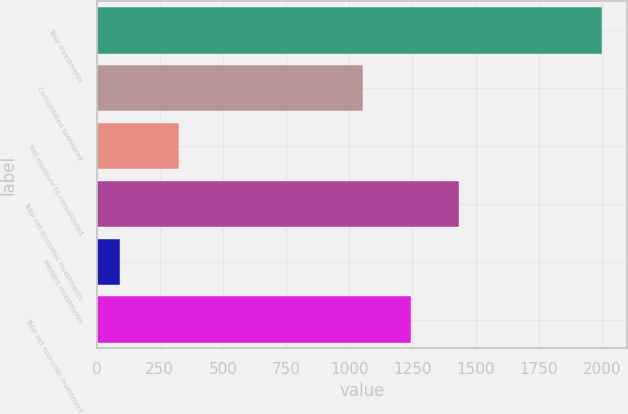Convert chart. <chart><loc_0><loc_0><loc_500><loc_500><bar_chart><fcel>Total investments<fcel>Consolidated sponsored<fcel>Net exposure to consolidated<fcel>Total net economic investments<fcel>Hedged investments<fcel>Total net economic investment<nl><fcel>2000<fcel>1054<fcel>325<fcel>1435.2<fcel>94<fcel>1244.6<nl></chart> 